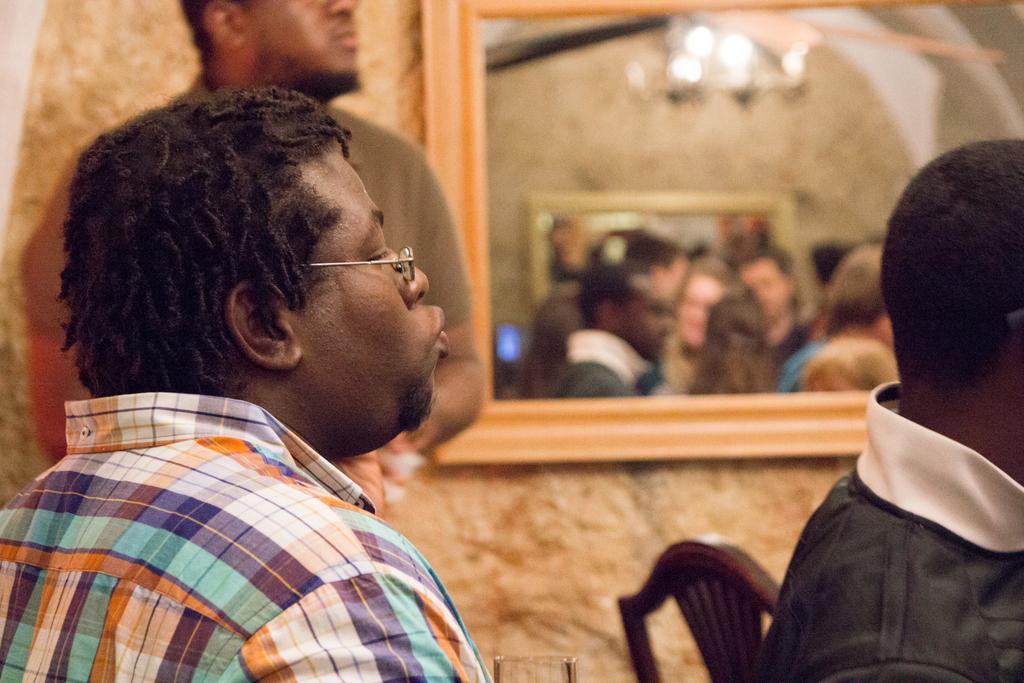In one or two sentences, can you explain what this image depicts? In this image we can see few people. Also there is a chair. In the back there is a wall with a mirror. In the mirror we can see reflections of people and chandelier. And it is blurry. 